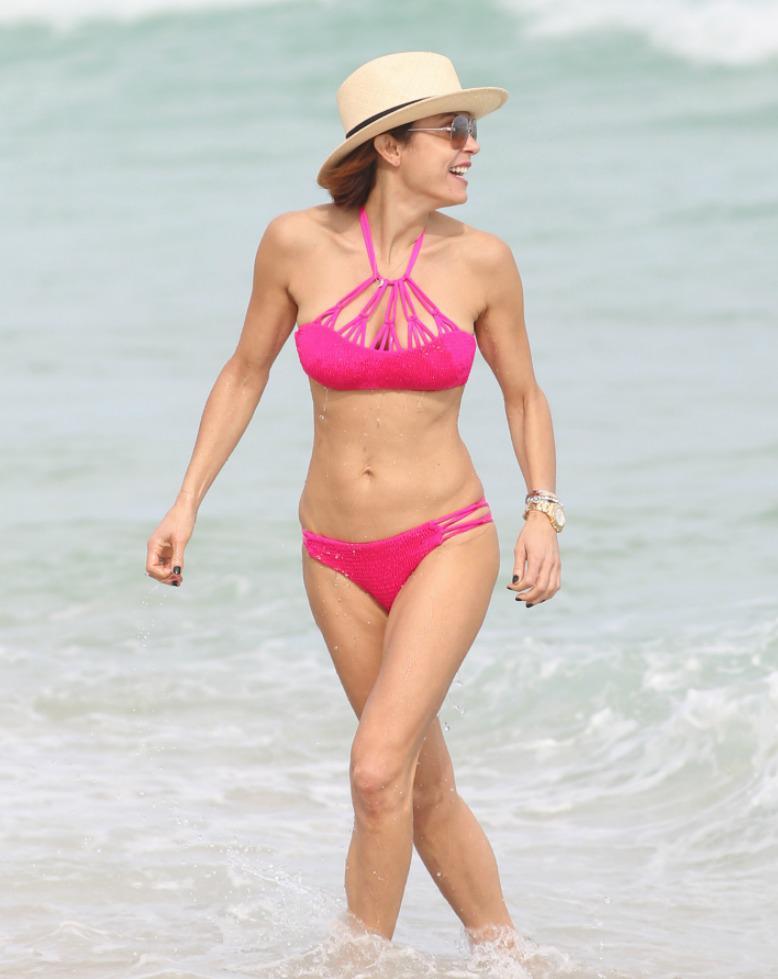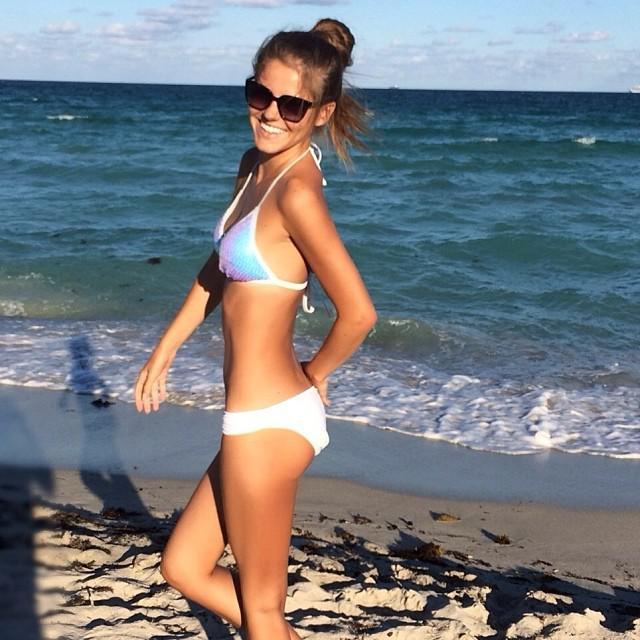The first image is the image on the left, the second image is the image on the right. Assess this claim about the two images: "The female on the right image has her hair tied up.". Correct or not? Answer yes or no. Yes. The first image is the image on the left, the second image is the image on the right. For the images shown, is this caption "One woman is standing in the water." true? Answer yes or no. Yes. 